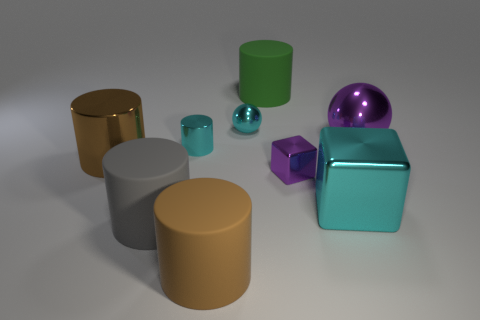Is the color of the large metallic cylinder the same as the big object that is in front of the large gray thing?
Offer a very short reply. Yes. What is the size of the cylinder that is the same color as the tiny ball?
Provide a succinct answer. Small. Are there any large things of the same color as the small cube?
Provide a succinct answer. Yes. The cyan metal object that is the same shape as the green matte thing is what size?
Your answer should be very brief. Small. There is a shiny thing that is behind the large shiny block and right of the small purple shiny thing; what is its size?
Provide a short and direct response. Large. What shape is the large metal object that is the same color as the tiny shiny block?
Your response must be concise. Sphere. What color is the tiny shiny cube?
Give a very brief answer. Purple. What is the size of the matte cylinder that is behind the gray cylinder?
Ensure brevity in your answer.  Large. There is a rubber cylinder that is behind the cyan thing that is behind the big purple metal thing; how many big brown objects are on the right side of it?
Offer a very short reply. 0. The matte thing behind the purple shiny thing that is in front of the big purple ball is what color?
Your answer should be very brief. Green. 